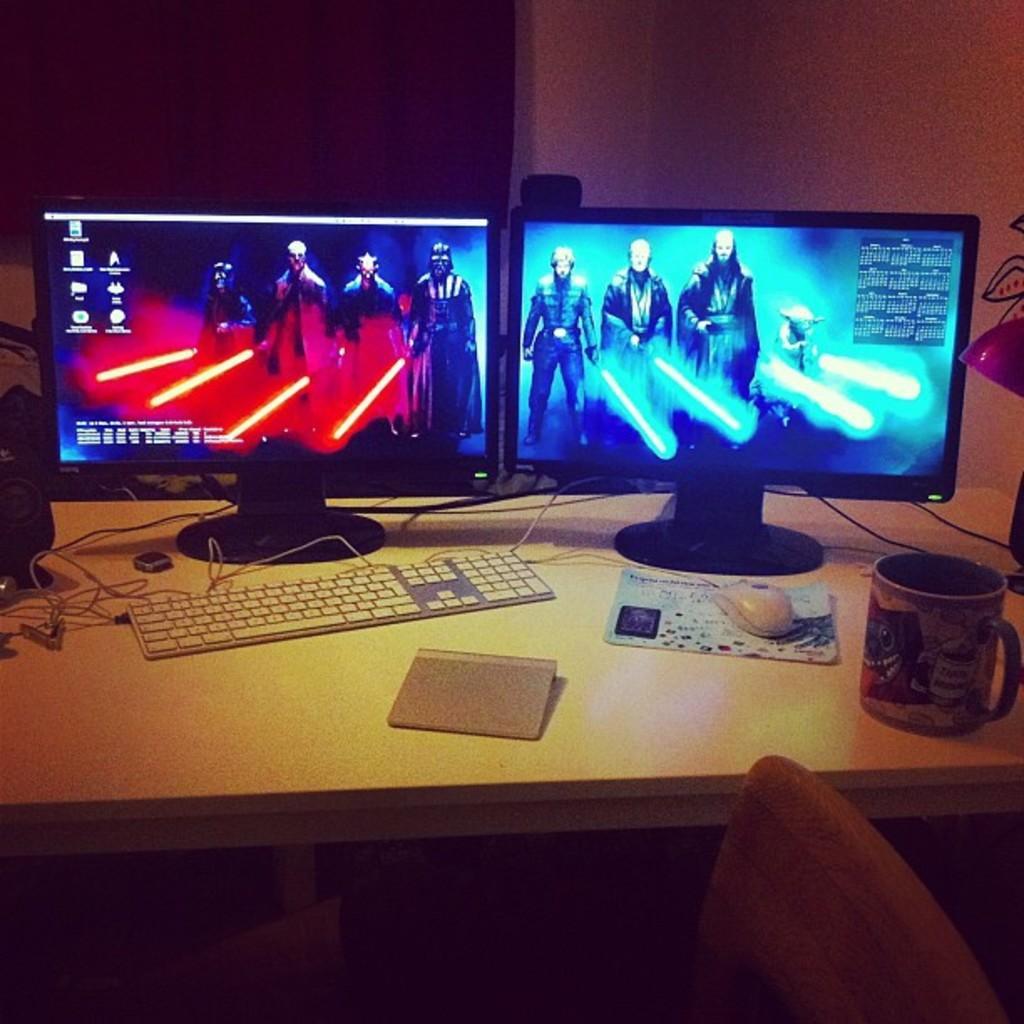In one or two sentences, can you explain what this image depicts? On this table there is a cpu, mouse, keyboard, cables and monitors. In-front of this table there is a chair. 